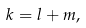<formula> <loc_0><loc_0><loc_500><loc_500>k = l + m ,</formula> 